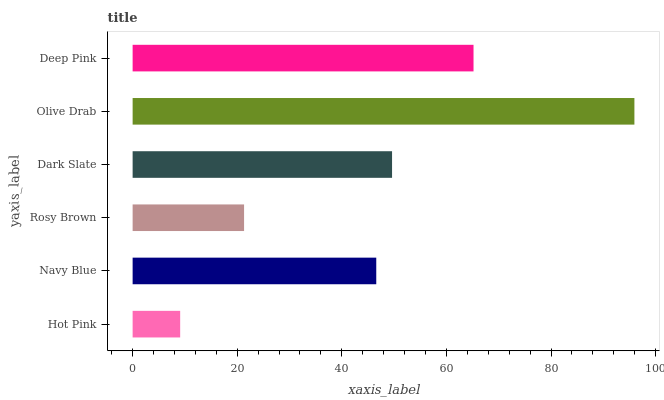Is Hot Pink the minimum?
Answer yes or no. Yes. Is Olive Drab the maximum?
Answer yes or no. Yes. Is Navy Blue the minimum?
Answer yes or no. No. Is Navy Blue the maximum?
Answer yes or no. No. Is Navy Blue greater than Hot Pink?
Answer yes or no. Yes. Is Hot Pink less than Navy Blue?
Answer yes or no. Yes. Is Hot Pink greater than Navy Blue?
Answer yes or no. No. Is Navy Blue less than Hot Pink?
Answer yes or no. No. Is Dark Slate the high median?
Answer yes or no. Yes. Is Navy Blue the low median?
Answer yes or no. Yes. Is Navy Blue the high median?
Answer yes or no. No. Is Dark Slate the low median?
Answer yes or no. No. 